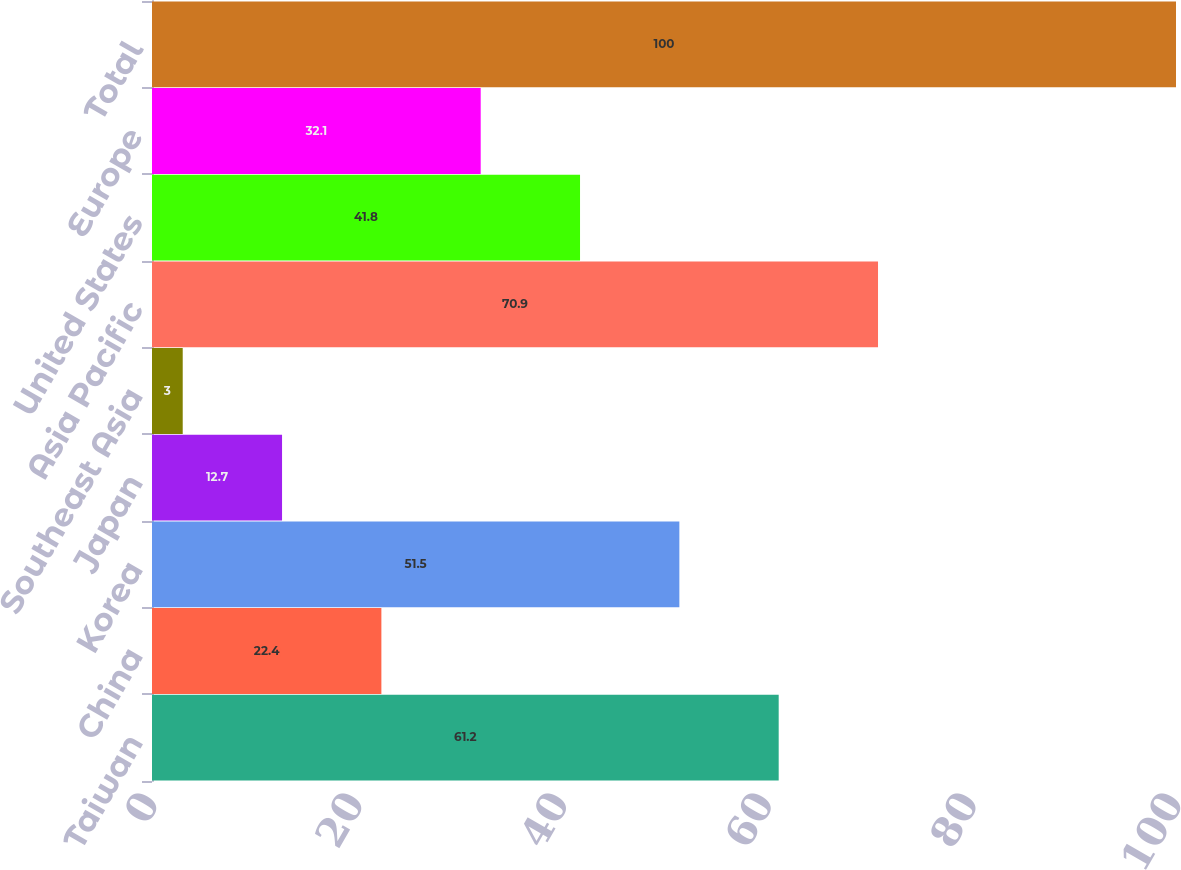<chart> <loc_0><loc_0><loc_500><loc_500><bar_chart><fcel>Taiwan<fcel>China<fcel>Korea<fcel>Japan<fcel>Southeast Asia<fcel>Asia Pacific<fcel>United States<fcel>Europe<fcel>Total<nl><fcel>61.2<fcel>22.4<fcel>51.5<fcel>12.7<fcel>3<fcel>70.9<fcel>41.8<fcel>32.1<fcel>100<nl></chart> 